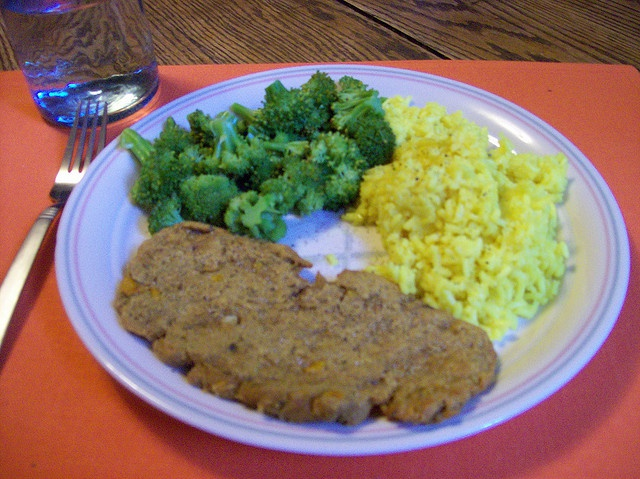Describe the objects in this image and their specific colors. I can see dining table in black, brown, and salmon tones, broccoli in black, darkgreen, green, and teal tones, cup in black, gray, maroon, and purple tones, and fork in black, ivory, gray, brown, and darkgray tones in this image. 